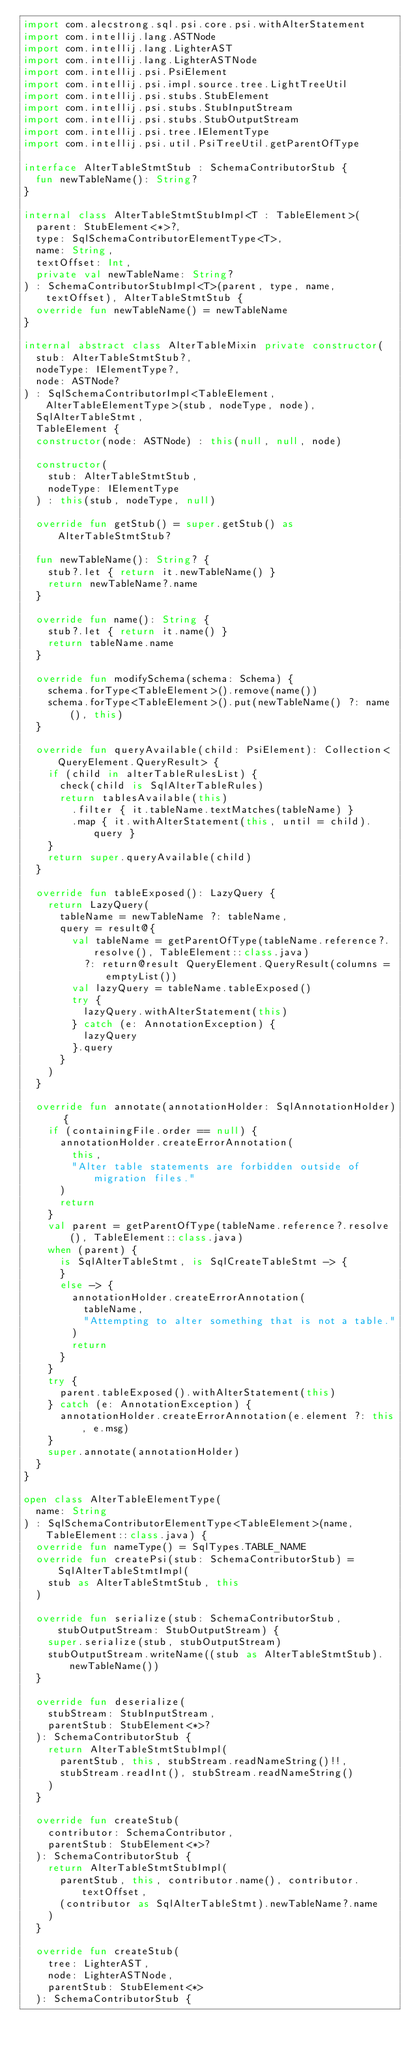Convert code to text. <code><loc_0><loc_0><loc_500><loc_500><_Kotlin_>import com.alecstrong.sql.psi.core.psi.withAlterStatement
import com.intellij.lang.ASTNode
import com.intellij.lang.LighterAST
import com.intellij.lang.LighterASTNode
import com.intellij.psi.PsiElement
import com.intellij.psi.impl.source.tree.LightTreeUtil
import com.intellij.psi.stubs.StubElement
import com.intellij.psi.stubs.StubInputStream
import com.intellij.psi.stubs.StubOutputStream
import com.intellij.psi.tree.IElementType
import com.intellij.psi.util.PsiTreeUtil.getParentOfType

interface AlterTableStmtStub : SchemaContributorStub {
  fun newTableName(): String?
}

internal class AlterTableStmtStubImpl<T : TableElement>(
  parent: StubElement<*>?,
  type: SqlSchemaContributorElementType<T>,
  name: String,
  textOffset: Int,
  private val newTableName: String?
) : SchemaContributorStubImpl<T>(parent, type, name, textOffset), AlterTableStmtStub {
  override fun newTableName() = newTableName
}

internal abstract class AlterTableMixin private constructor(
  stub: AlterTableStmtStub?,
  nodeType: IElementType?,
  node: ASTNode?
) : SqlSchemaContributorImpl<TableElement, AlterTableElementType>(stub, nodeType, node),
  SqlAlterTableStmt,
  TableElement {
  constructor(node: ASTNode) : this(null, null, node)

  constructor(
    stub: AlterTableStmtStub,
    nodeType: IElementType
  ) : this(stub, nodeType, null)

  override fun getStub() = super.getStub() as AlterTableStmtStub?

  fun newTableName(): String? {
    stub?.let { return it.newTableName() }
    return newTableName?.name
  }

  override fun name(): String {
    stub?.let { return it.name() }
    return tableName.name
  }

  override fun modifySchema(schema: Schema) {
    schema.forType<TableElement>().remove(name())
    schema.forType<TableElement>().put(newTableName() ?: name(), this)
  }

  override fun queryAvailable(child: PsiElement): Collection<QueryElement.QueryResult> {
    if (child in alterTableRulesList) {
      check(child is SqlAlterTableRules)
      return tablesAvailable(this)
        .filter { it.tableName.textMatches(tableName) }
        .map { it.withAlterStatement(this, until = child).query }
    }
    return super.queryAvailable(child)
  }

  override fun tableExposed(): LazyQuery {
    return LazyQuery(
      tableName = newTableName ?: tableName,
      query = result@{
        val tableName = getParentOfType(tableName.reference?.resolve(), TableElement::class.java)
          ?: return@result QueryElement.QueryResult(columns = emptyList())
        val lazyQuery = tableName.tableExposed()
        try {
          lazyQuery.withAlterStatement(this)
        } catch (e: AnnotationException) {
          lazyQuery
        }.query
      }
    )
  }

  override fun annotate(annotationHolder: SqlAnnotationHolder) {
    if (containingFile.order == null) {
      annotationHolder.createErrorAnnotation(
        this,
        "Alter table statements are forbidden outside of migration files."
      )
      return
    }
    val parent = getParentOfType(tableName.reference?.resolve(), TableElement::class.java)
    when (parent) {
      is SqlAlterTableStmt, is SqlCreateTableStmt -> {
      }
      else -> {
        annotationHolder.createErrorAnnotation(
          tableName,
          "Attempting to alter something that is not a table."
        )
        return
      }
    }
    try {
      parent.tableExposed().withAlterStatement(this)
    } catch (e: AnnotationException) {
      annotationHolder.createErrorAnnotation(e.element ?: this, e.msg)
    }
    super.annotate(annotationHolder)
  }
}

open class AlterTableElementType(
  name: String
) : SqlSchemaContributorElementType<TableElement>(name, TableElement::class.java) {
  override fun nameType() = SqlTypes.TABLE_NAME
  override fun createPsi(stub: SchemaContributorStub) = SqlAlterTableStmtImpl(
    stub as AlterTableStmtStub, this
  )

  override fun serialize(stub: SchemaContributorStub, stubOutputStream: StubOutputStream) {
    super.serialize(stub, stubOutputStream)
    stubOutputStream.writeName((stub as AlterTableStmtStub).newTableName())
  }

  override fun deserialize(
    stubStream: StubInputStream,
    parentStub: StubElement<*>?
  ): SchemaContributorStub {
    return AlterTableStmtStubImpl(
      parentStub, this, stubStream.readNameString()!!,
      stubStream.readInt(), stubStream.readNameString()
    )
  }

  override fun createStub(
    contributor: SchemaContributor,
    parentStub: StubElement<*>?
  ): SchemaContributorStub {
    return AlterTableStmtStubImpl(
      parentStub, this, contributor.name(), contributor.textOffset,
      (contributor as SqlAlterTableStmt).newTableName?.name
    )
  }

  override fun createStub(
    tree: LighterAST,
    node: LighterASTNode,
    parentStub: StubElement<*>
  ): SchemaContributorStub {</code> 